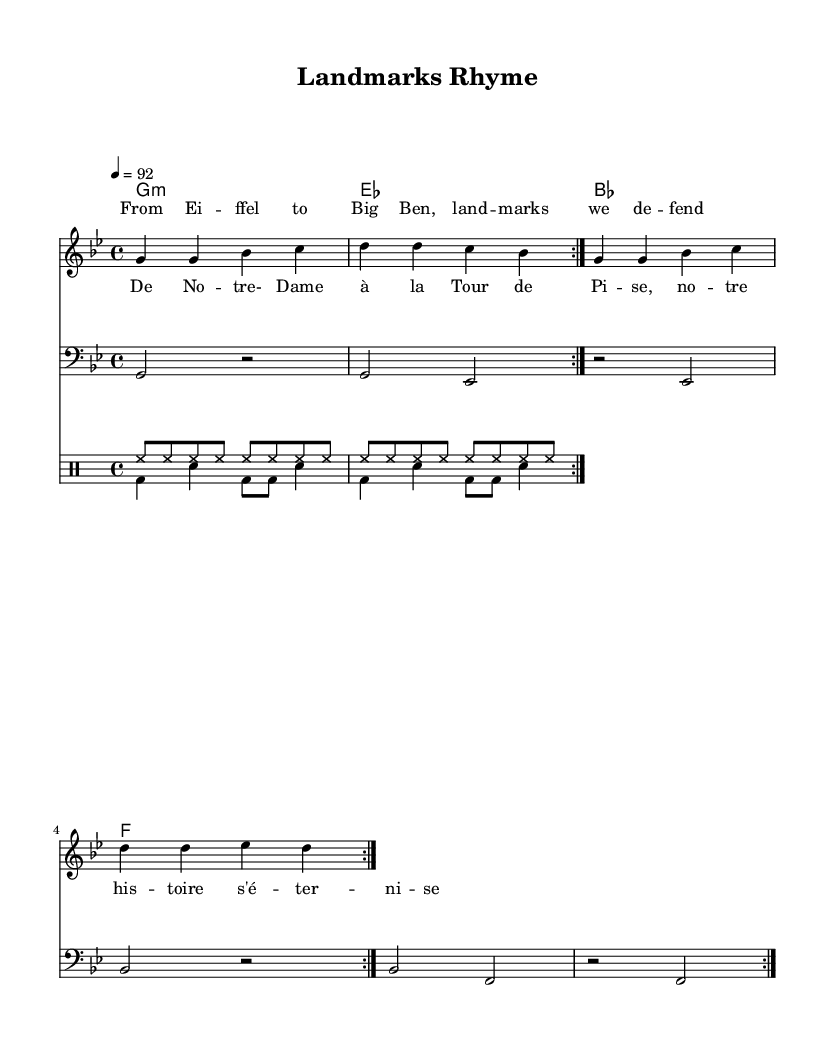What is the key signature of this music? The key signature is G minor, which has two flats (B flat and E flat). This information is indicated at the beginning of the staff notation.
Answer: G minor What is the time signature used in this piece? The time signature is four-four, which is shown as a fraction at the beginning of the sheet music. This means there are four beats per measure, and the quarter note gets one beat.
Answer: Four-four What is the tempo marking for the piece? The tempo marking is 92 beats per minute, which is noted above the staff as "4 = 92." This indicates the speed at which the piece should be played.
Answer: 92 How many measures are repeated in the melody? The melody contains two measures that are specifically marked to be repeated. This repetition is indicated by the volta markings in the score.
Answer: Two measures What types of drums are indicated in the drum part? The drum part contains two types of drums: hi-hat (hh) and bass drum (bd), as well as snare drum (sn). These are commonly used in hip hop to create rhythmic patterns.
Answer: Hi-hat, bass drum, and snare drum What landmarks are mentioned in the lyrics? The lyrics mention two landmarks: Eiffel Tower and Big Ben. These are referenced in a bilingual context, illustrating the essence of a bridge between French and English cultural icons.
Answer: Eiffel Tower and Big Ben How is the harmony structured in this piece? The harmony is structured with four chords: G minor, E flat major, B flat major, and F major. This progression supports the melody and adds richness to the musical piece.
Answer: G minor, E flat major, B flat major, and F major 